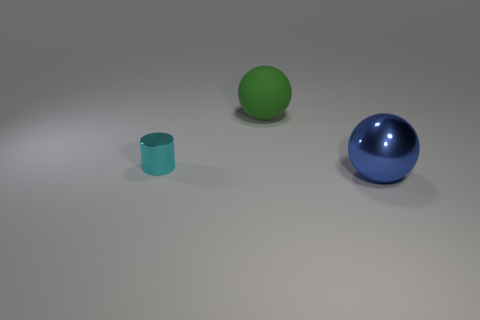There is a object left of the big ball that is on the left side of the big blue metal thing; what is its shape?
Make the answer very short. Cylinder. What number of green things are either big things or small cylinders?
Give a very brief answer. 1. What color is the cylinder?
Your response must be concise. Cyan. Is the size of the rubber sphere the same as the blue metal object?
Ensure brevity in your answer.  Yes. Are there any other things that have the same shape as the small shiny object?
Ensure brevity in your answer.  No. Does the big blue thing have the same material as the tiny cyan object in front of the rubber sphere?
Your answer should be very brief. Yes. Does the shiny thing in front of the cyan metal cylinder have the same color as the metal cylinder?
Your answer should be very brief. No. How many large objects are both in front of the cyan cylinder and behind the cylinder?
Provide a short and direct response. 0. How many other things are the same material as the cylinder?
Your answer should be compact. 1. Do the large ball that is in front of the cyan object and the cyan thing have the same material?
Provide a succinct answer. Yes. 